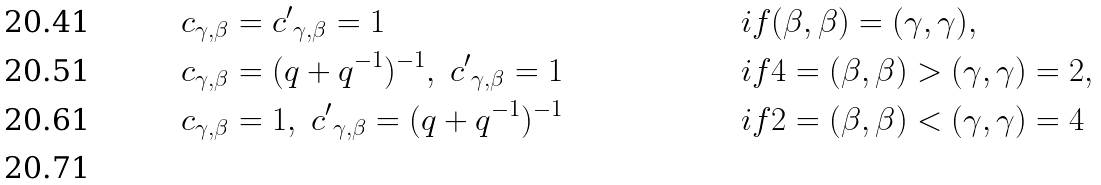Convert formula to latex. <formula><loc_0><loc_0><loc_500><loc_500>& c _ { \gamma , \beta } = { c ^ { \prime } } _ { \gamma , \beta } = 1 & & { i f } ( \beta , \beta ) = ( \gamma , \gamma ) , & \\ & c _ { \gamma , \beta } = ( q + q ^ { - 1 } ) ^ { - 1 } , \ { c ^ { \prime } } _ { \gamma , \beta } = 1 & & { i f } 4 = ( \beta , \beta ) > ( \gamma , \gamma ) = 2 , & \\ & c _ { \gamma , \beta } = 1 , \ { c ^ { \prime } } _ { \gamma , \beta } = ( q + q ^ { - 1 } ) ^ { - 1 } & & { i f } 2 = ( \beta , \beta ) < ( \gamma , \gamma ) = 4 & \\</formula> 